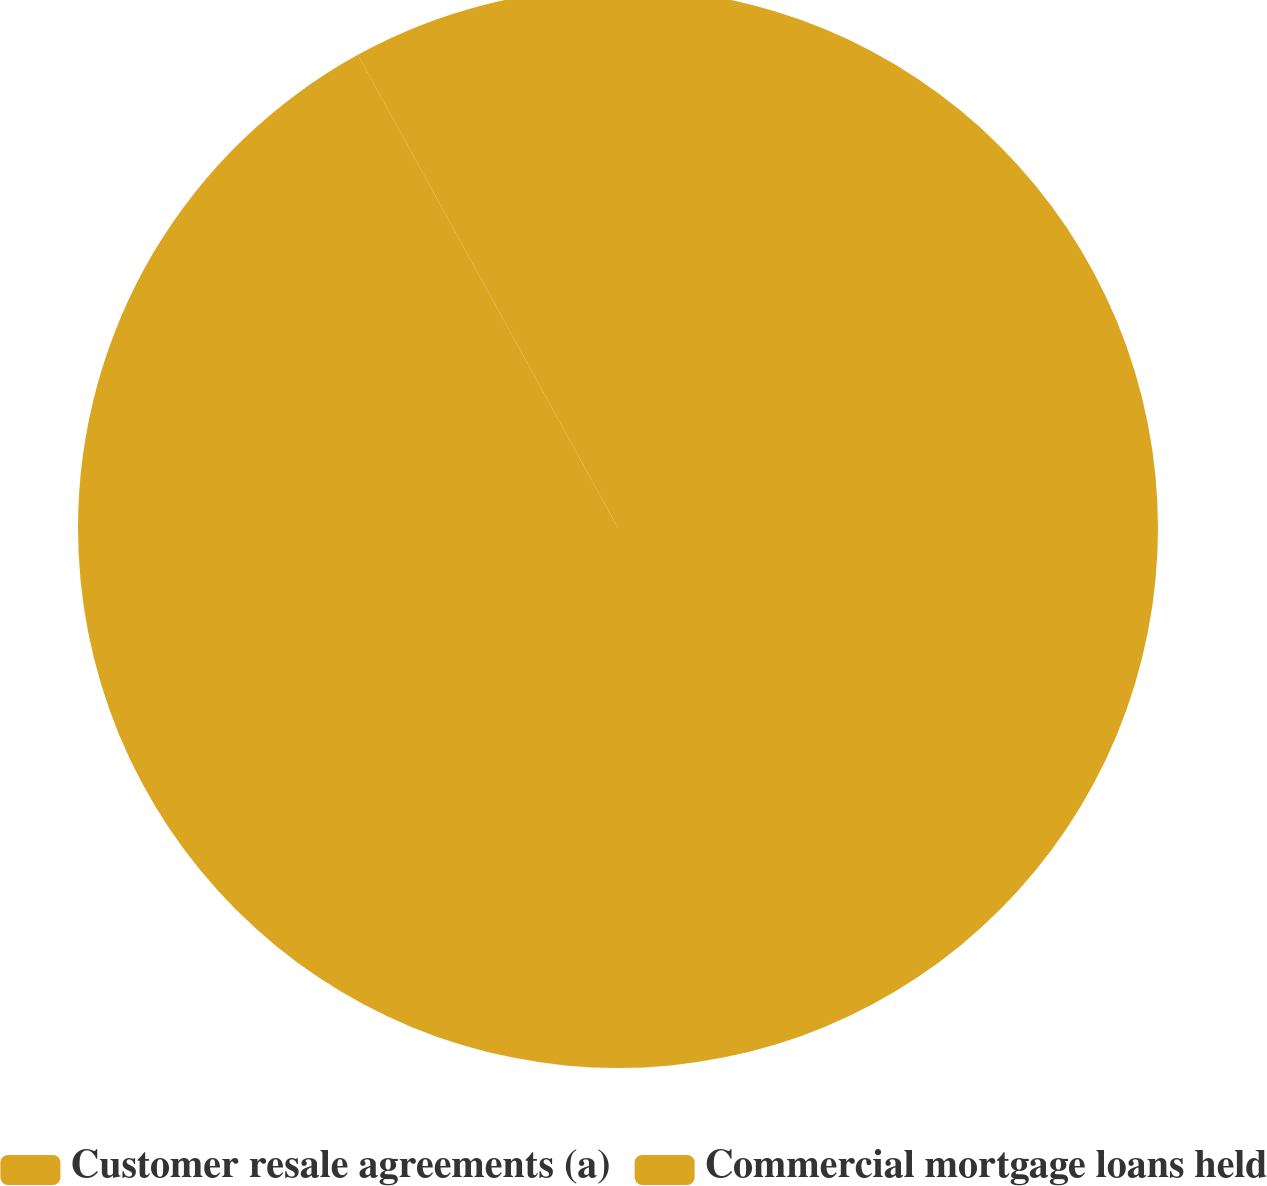<chart> <loc_0><loc_0><loc_500><loc_500><pie_chart><fcel>Customer resale agreements (a)<fcel>Commercial mortgage loans held<nl><fcel>92.0%<fcel>8.0%<nl></chart> 